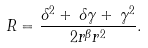<formula> <loc_0><loc_0><loc_500><loc_500>R = \frac { { \delta } ^ { 2 } + \, \delta \gamma + \, { \gamma } ^ { 2 } } { 2 { r } ^ { \beta } { r } ^ { 2 } } .</formula> 